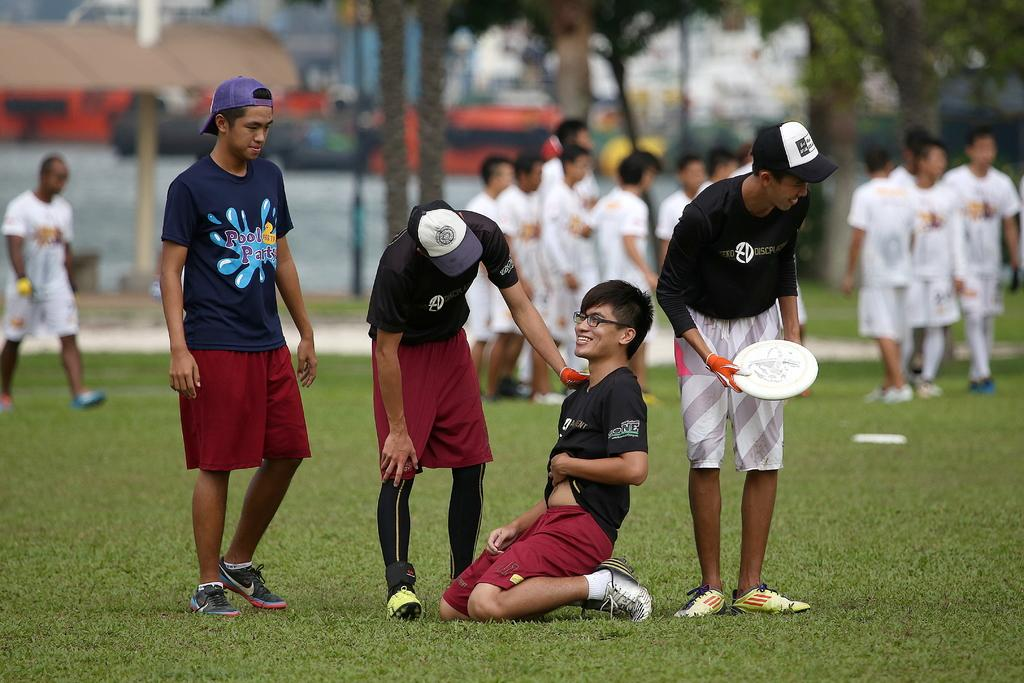What is happening in the image? There are players in the image, and they are standing in a ground. Can you describe the position of one of the players? One player is laying on their knees. What can be observed about the background of the image? The background of the image is blurred. What type of road can be seen in the image? There is no road present in the image; it features players standing in a ground. What is the purpose of the spade in the image? There is no spade present in the image. 